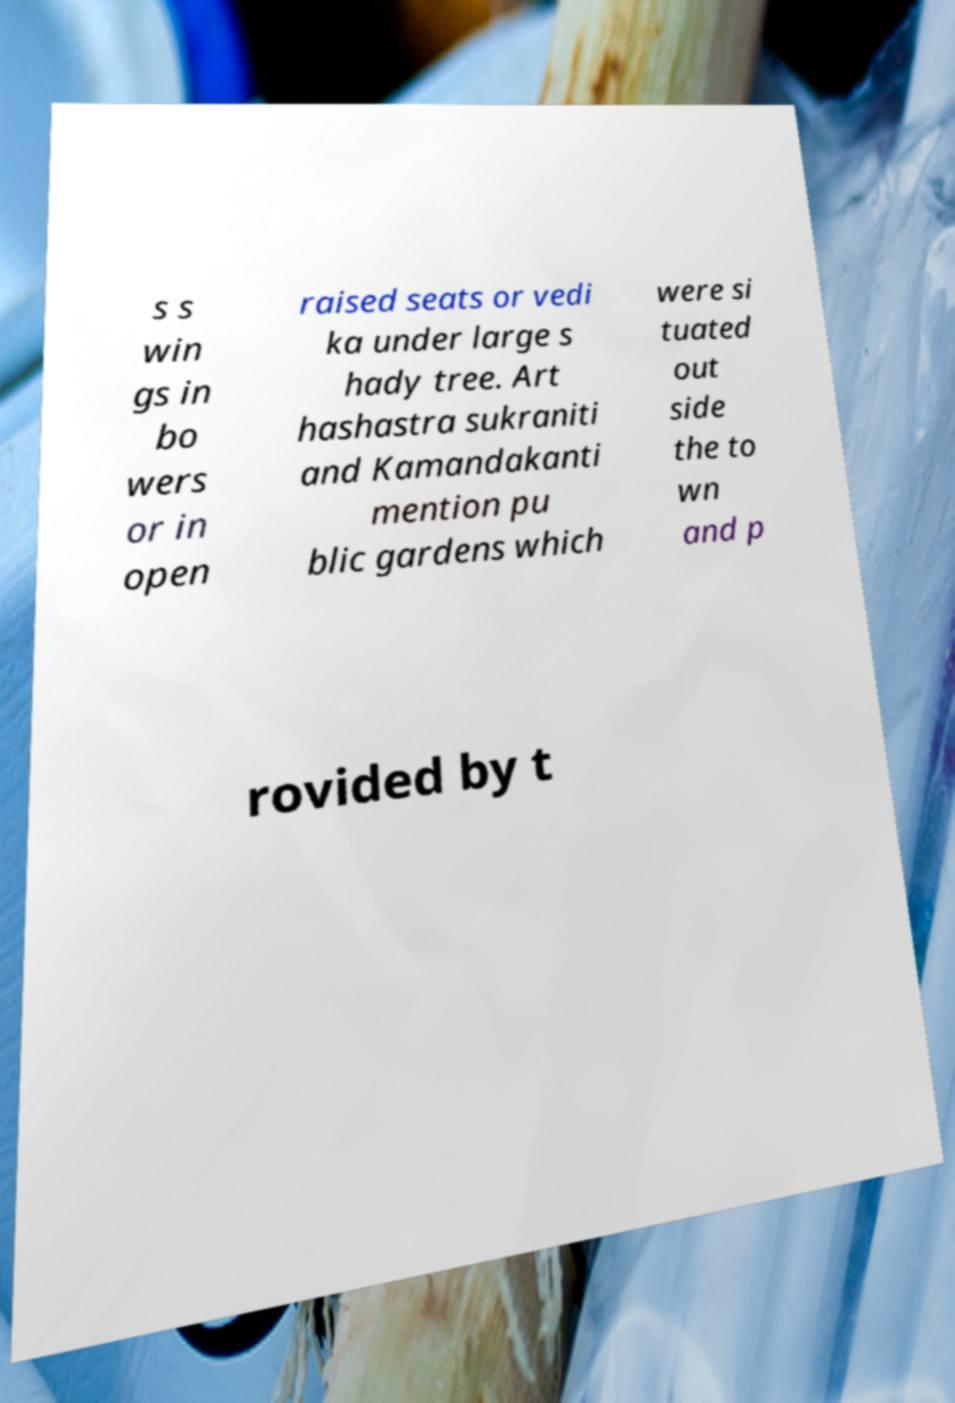Can you read and provide the text displayed in the image?This photo seems to have some interesting text. Can you extract and type it out for me? s s win gs in bo wers or in open raised seats or vedi ka under large s hady tree. Art hashastra sukraniti and Kamandakanti mention pu blic gardens which were si tuated out side the to wn and p rovided by t 